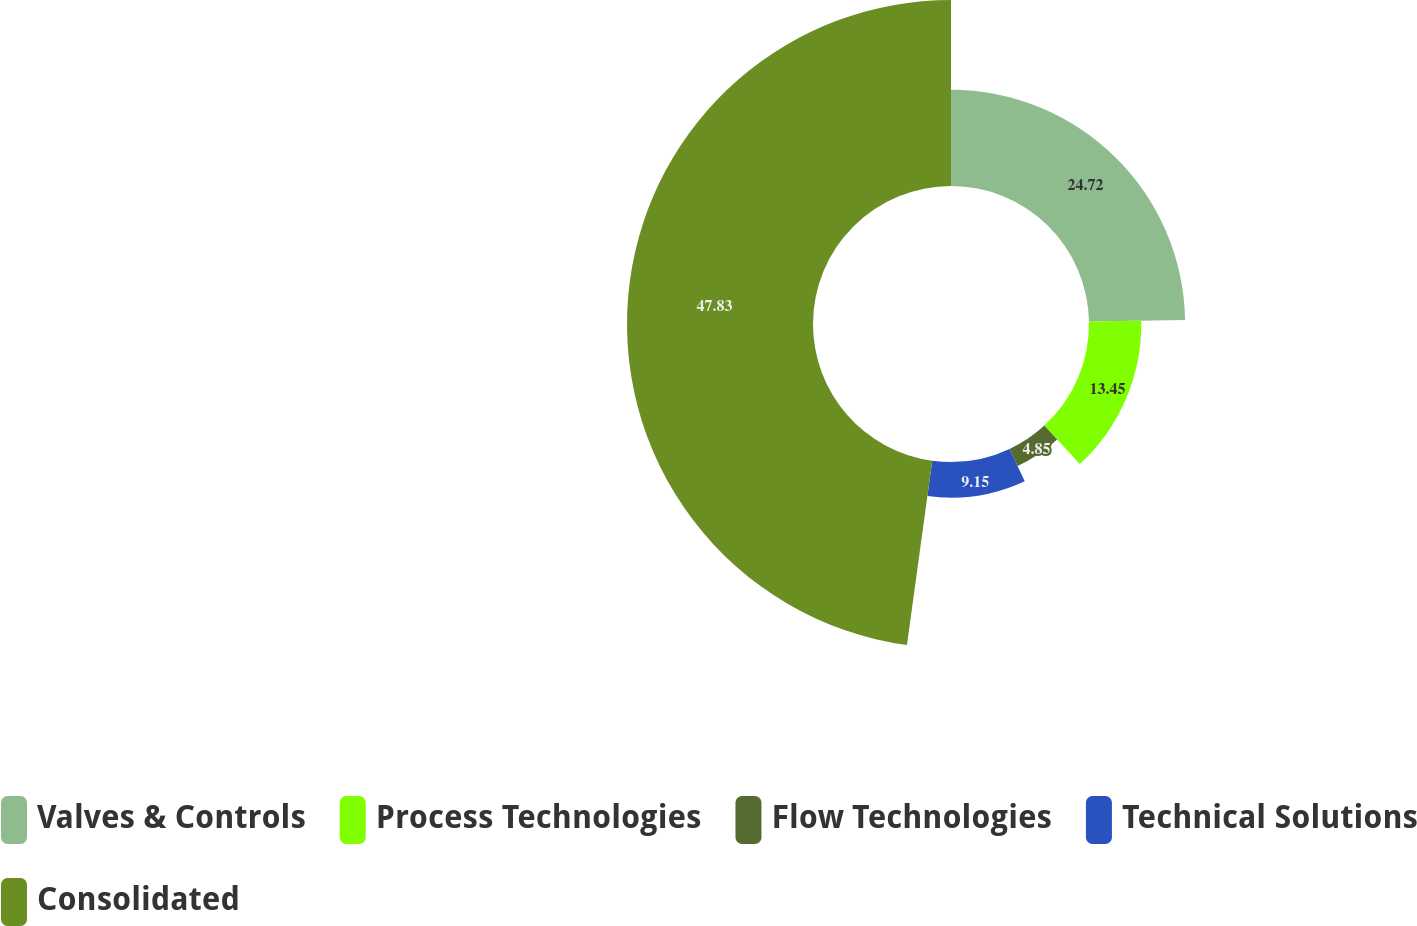<chart> <loc_0><loc_0><loc_500><loc_500><pie_chart><fcel>Valves & Controls<fcel>Process Technologies<fcel>Flow Technologies<fcel>Technical Solutions<fcel>Consolidated<nl><fcel>24.72%<fcel>13.45%<fcel>4.85%<fcel>9.15%<fcel>47.83%<nl></chart> 